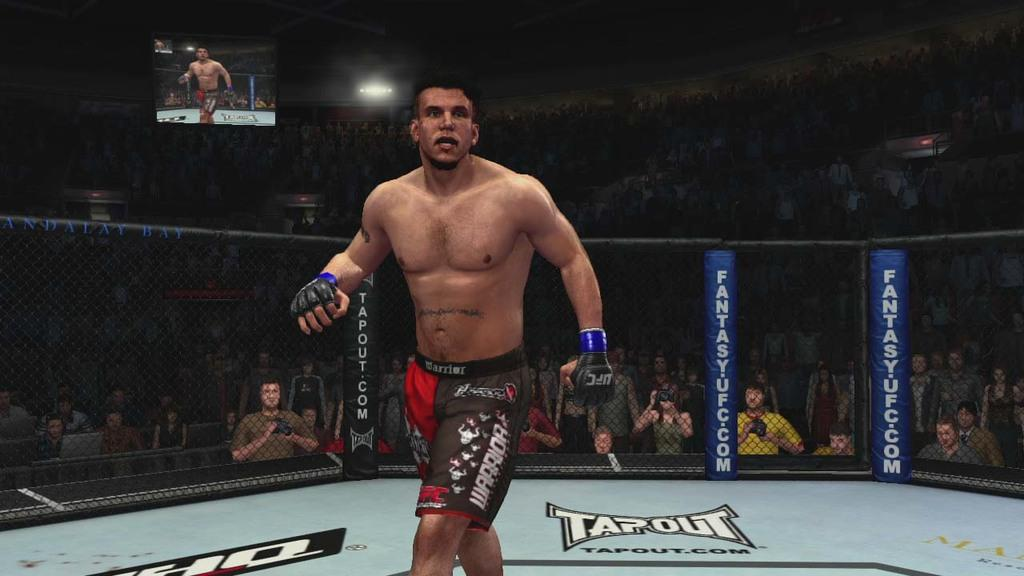<image>
Describe the image concisely. MMA fighter in a ring that says Tapout on the ground. 